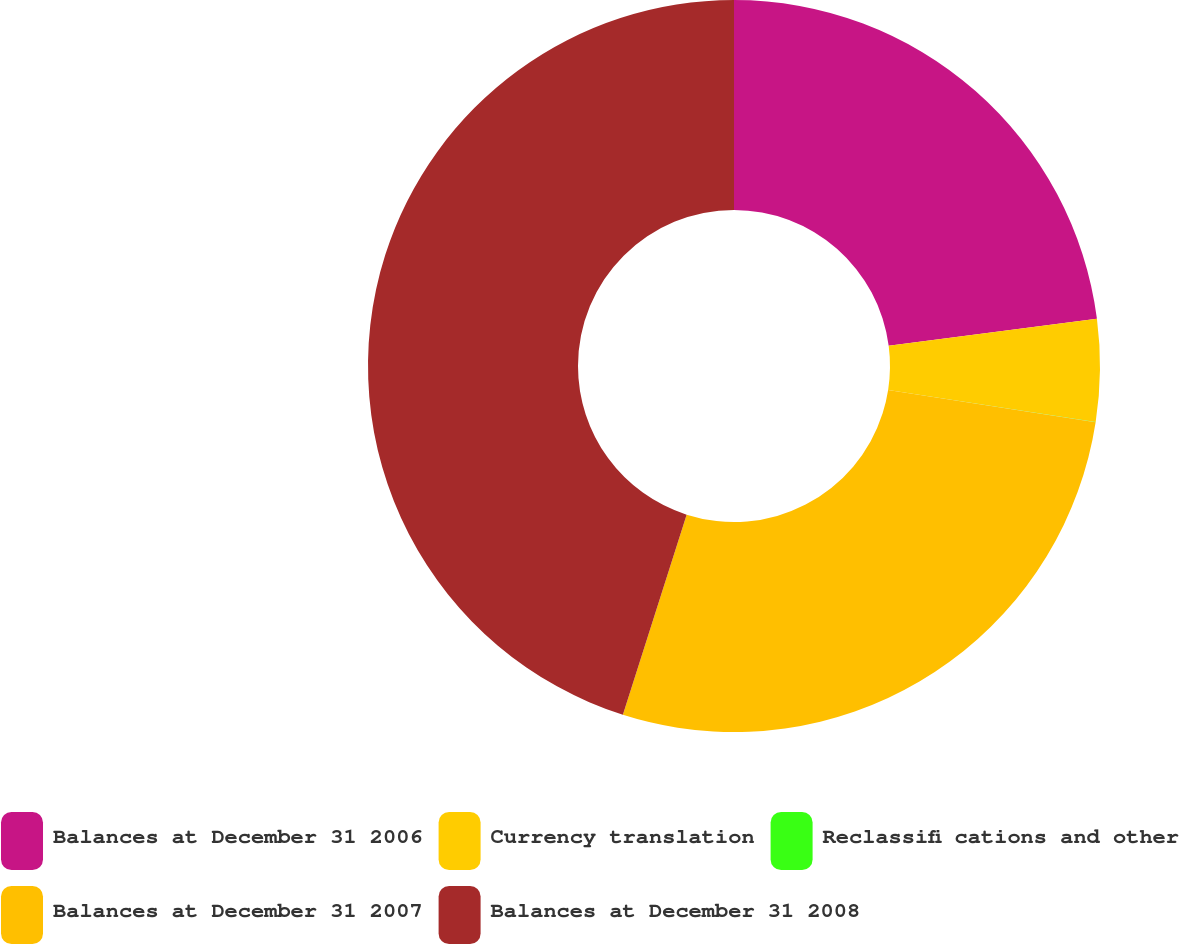<chart> <loc_0><loc_0><loc_500><loc_500><pie_chart><fcel>Balances at December 31 2006<fcel>Currency translation<fcel>Reclassifi cations and other<fcel>Balances at December 31 2007<fcel>Balances at December 31 2008<nl><fcel>22.94%<fcel>4.51%<fcel>0.01%<fcel>27.45%<fcel>45.09%<nl></chart> 